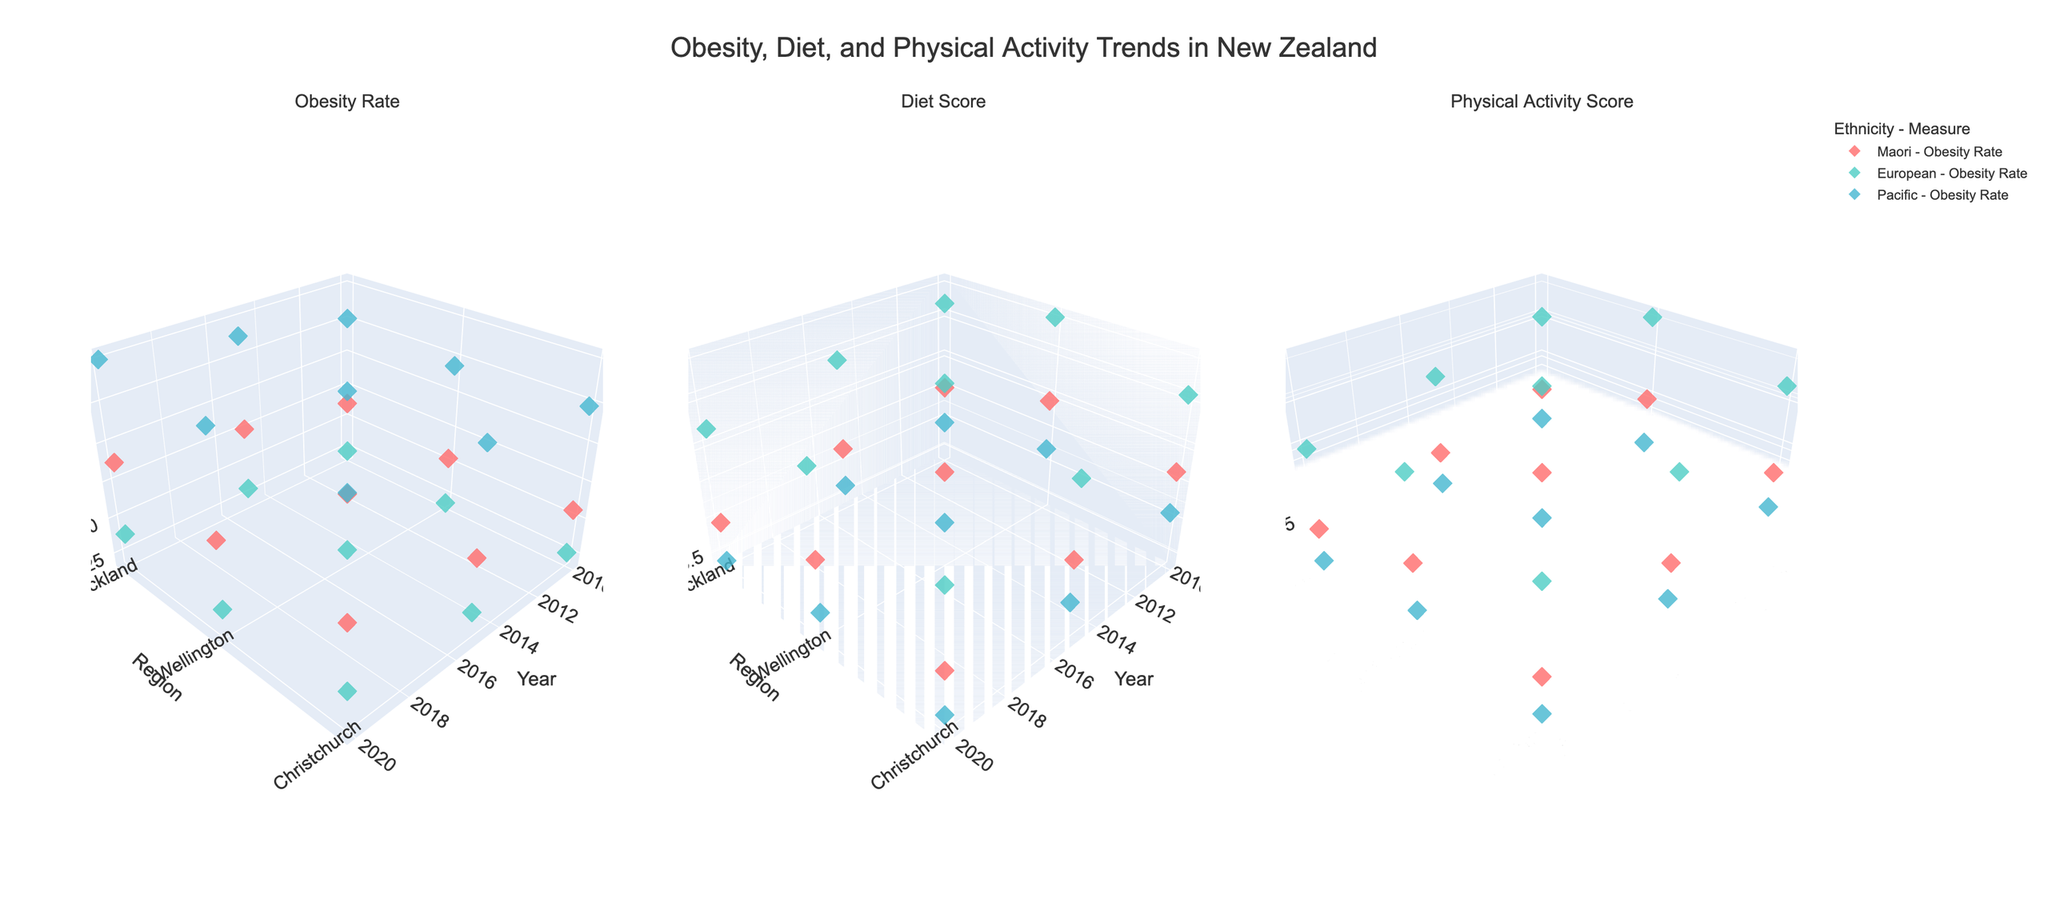What are the subplot titles? The figure contains subplots with titles displayed at the top of each subplot. The titles are "Obesity Rate," "Diet Score," and "Physical Activity Score."
Answer: Obesity Rate, Diet Score, Physical Activity Score What does the color of the markers represent? The figure uses different colors to represent different ethnic groups. There are three colors used, each corresponding to one of the ethnicities: Maori, European, and Pacific.
Answer: Different ethnic groups Which region shows the highest obesity rate for the Pacific group in 2020? To find this, locate the subplot for Obesity Rate and look for data points from 2020 for the Pacific group in Auckland, Wellington, and Christchurch. The marker at Auckland has the highest z-value.
Answer: Auckland Is there any trend observed in the Diet Score for the European group over the years? Examine the subplot for Diet Score and trace the markers for the European group. From 2010 to 2020, there is a slight decreasing trend in the Diet Score for all regions (Auckland, Wellington, Christchurch).
Answer: Slight decrease Which ethnic group has the highest Physical Activity Score in Wellington in 2015? Look at the subplot for Physical Activity Score and identify the markers for the year 2015 in Wellington. Compare the z-values for Maori, European, and Pacific groups. The European group has the highest score.
Answer: European Compare the change in obesity rates from 2010 to 2020 for the Maori and European groups in Auckland. By examining the markers for Auckland in the Obesity Rate subplot, the Maori group's rate increased from 32.5 to 37.6, while the European group's rate increased from 24.7 to 27.8.
Answer: Maori (+5.1), European (+3.1) Which ethnic group had the least improvement in Diet Score from 2010 to 2020 in Christchurch? Identify the Diet Scores for the years 2010 and 2020 in Christchurch for all ethnic groups. The group with the smallest or negative change in Diet Score shows the least improvement. For the Pacific group, the score declined from 5.9 to 5.5.
Answer: Pacific What is the general relationship between obesity rates and physical activity scores across all ethnicities and regions? By comparing the subplots for Obesity Rate and Physical Activity Score, it's observable that higher obesity rates tend to coincide with lower physical activity scores, indicating a potential inverse relationship.
Answer: Inverse relationship 